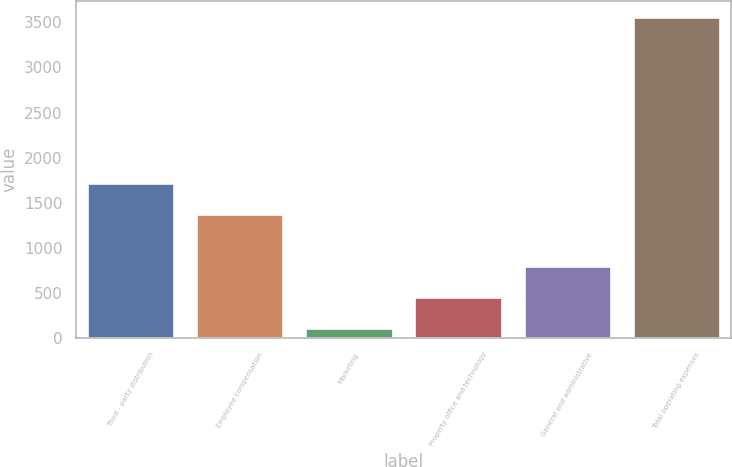<chart> <loc_0><loc_0><loc_500><loc_500><bar_chart><fcel>Third - party distribution<fcel>Employee compensation<fcel>Marketing<fcel>Property office and technology<fcel>General and administrative<fcel>Total operating expenses<nl><fcel>1723.12<fcel>1378.8<fcel>114.8<fcel>459.12<fcel>803.44<fcel>3558<nl></chart> 